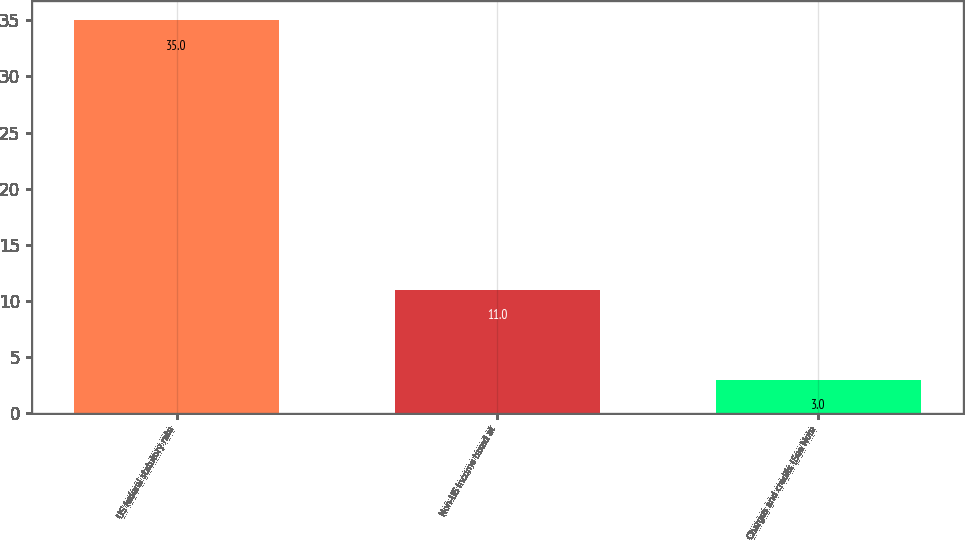<chart> <loc_0><loc_0><loc_500><loc_500><bar_chart><fcel>US federal statutory rate<fcel>Non-US income taxed at<fcel>Charges and credits (See Note<nl><fcel>35<fcel>11<fcel>3<nl></chart> 